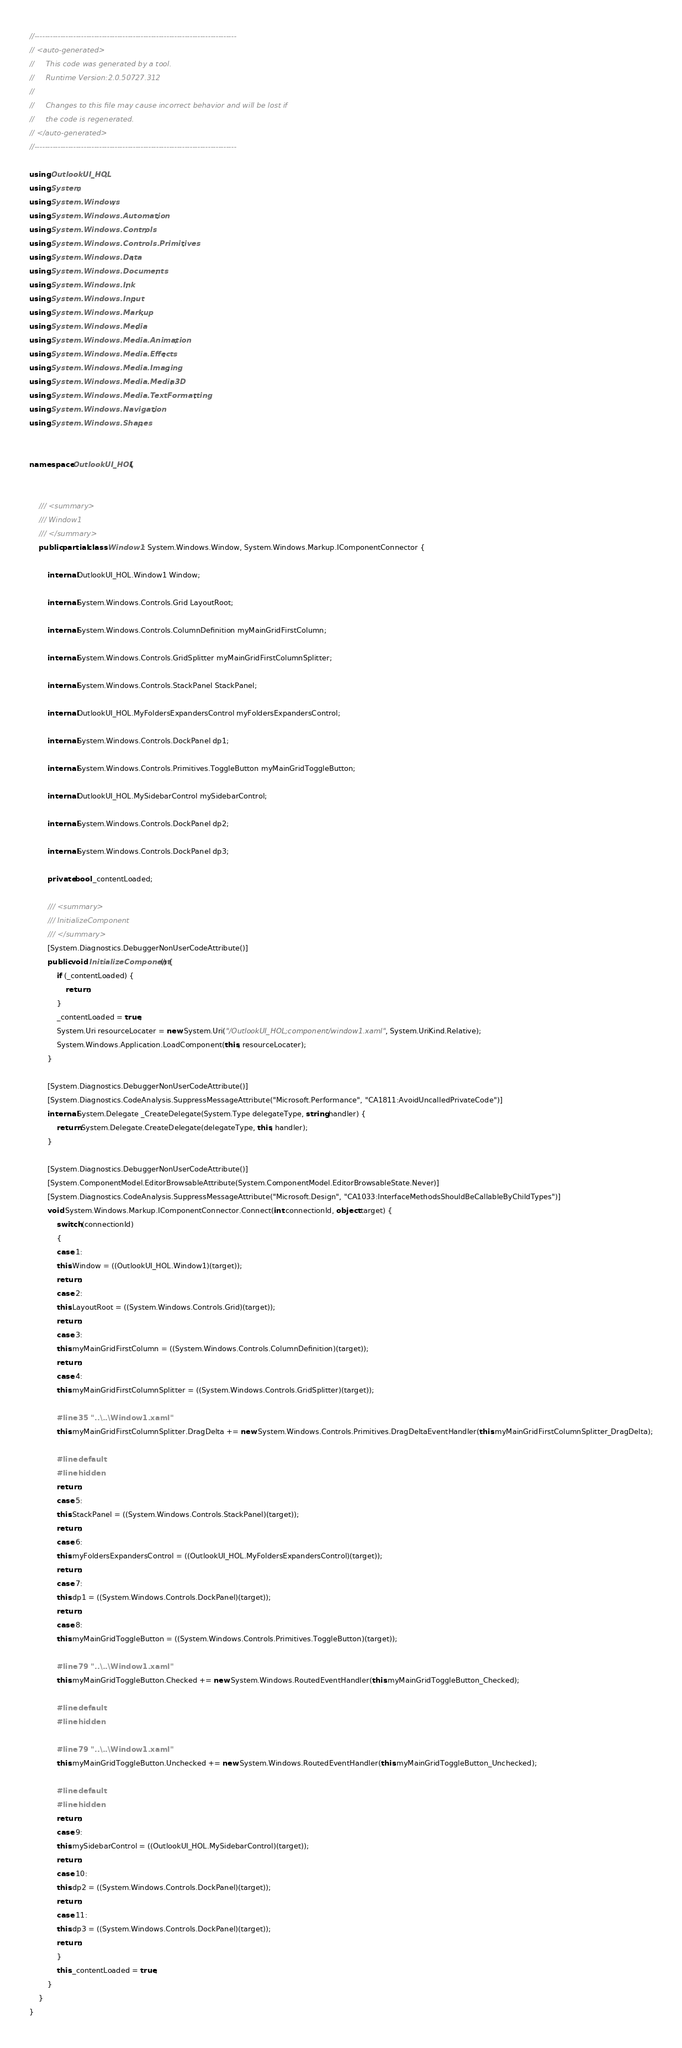<code> <loc_0><loc_0><loc_500><loc_500><_C#_>//------------------------------------------------------------------------------
// <auto-generated>
//     This code was generated by a tool.
//     Runtime Version:2.0.50727.312
//
//     Changes to this file may cause incorrect behavior and will be lost if
//     the code is regenerated.
// </auto-generated>
//------------------------------------------------------------------------------

using OutlookUI_HOL;
using System;
using System.Windows;
using System.Windows.Automation;
using System.Windows.Controls;
using System.Windows.Controls.Primitives;
using System.Windows.Data;
using System.Windows.Documents;
using System.Windows.Ink;
using System.Windows.Input;
using System.Windows.Markup;
using System.Windows.Media;
using System.Windows.Media.Animation;
using System.Windows.Media.Effects;
using System.Windows.Media.Imaging;
using System.Windows.Media.Media3D;
using System.Windows.Media.TextFormatting;
using System.Windows.Navigation;
using System.Windows.Shapes;


namespace OutlookUI_HOL {
    
    
    /// <summary>
    /// Window1
    /// </summary>
    public partial class Window1 : System.Windows.Window, System.Windows.Markup.IComponentConnector {
        
        internal OutlookUI_HOL.Window1 Window;
        
        internal System.Windows.Controls.Grid LayoutRoot;
        
        internal System.Windows.Controls.ColumnDefinition myMainGridFirstColumn;
        
        internal System.Windows.Controls.GridSplitter myMainGridFirstColumnSplitter;
        
        internal System.Windows.Controls.StackPanel StackPanel;
        
        internal OutlookUI_HOL.MyFoldersExpandersControl myFoldersExpandersControl;
        
        internal System.Windows.Controls.DockPanel dp1;
        
        internal System.Windows.Controls.Primitives.ToggleButton myMainGridToggleButton;
        
        internal OutlookUI_HOL.MySidebarControl mySidebarControl;
        
        internal System.Windows.Controls.DockPanel dp2;
        
        internal System.Windows.Controls.DockPanel dp3;
        
        private bool _contentLoaded;
        
        /// <summary>
        /// InitializeComponent
        /// </summary>
        [System.Diagnostics.DebuggerNonUserCodeAttribute()]
        public void InitializeComponent() {
            if (_contentLoaded) {
                return;
            }
            _contentLoaded = true;
            System.Uri resourceLocater = new System.Uri("/OutlookUI_HOL;component/window1.xaml", System.UriKind.Relative);
            System.Windows.Application.LoadComponent(this, resourceLocater);
        }
        
        [System.Diagnostics.DebuggerNonUserCodeAttribute()]
        [System.Diagnostics.CodeAnalysis.SuppressMessageAttribute("Microsoft.Performance", "CA1811:AvoidUncalledPrivateCode")]
        internal System.Delegate _CreateDelegate(System.Type delegateType, string handler) {
            return System.Delegate.CreateDelegate(delegateType, this, handler);
        }
        
        [System.Diagnostics.DebuggerNonUserCodeAttribute()]
        [System.ComponentModel.EditorBrowsableAttribute(System.ComponentModel.EditorBrowsableState.Never)]
        [System.Diagnostics.CodeAnalysis.SuppressMessageAttribute("Microsoft.Design", "CA1033:InterfaceMethodsShouldBeCallableByChildTypes")]
        void System.Windows.Markup.IComponentConnector.Connect(int connectionId, object target) {
            switch (connectionId)
            {
            case 1:
            this.Window = ((OutlookUI_HOL.Window1)(target));
            return;
            case 2:
            this.LayoutRoot = ((System.Windows.Controls.Grid)(target));
            return;
            case 3:
            this.myMainGridFirstColumn = ((System.Windows.Controls.ColumnDefinition)(target));
            return;
            case 4:
            this.myMainGridFirstColumnSplitter = ((System.Windows.Controls.GridSplitter)(target));
            
            #line 35 "..\..\Window1.xaml"
            this.myMainGridFirstColumnSplitter.DragDelta += new System.Windows.Controls.Primitives.DragDeltaEventHandler(this.myMainGridFirstColumnSplitter_DragDelta);
            
            #line default
            #line hidden
            return;
            case 5:
            this.StackPanel = ((System.Windows.Controls.StackPanel)(target));
            return;
            case 6:
            this.myFoldersExpandersControl = ((OutlookUI_HOL.MyFoldersExpandersControl)(target));
            return;
            case 7:
            this.dp1 = ((System.Windows.Controls.DockPanel)(target));
            return;
            case 8:
            this.myMainGridToggleButton = ((System.Windows.Controls.Primitives.ToggleButton)(target));
            
            #line 79 "..\..\Window1.xaml"
            this.myMainGridToggleButton.Checked += new System.Windows.RoutedEventHandler(this.myMainGridToggleButton_Checked);
            
            #line default
            #line hidden
            
            #line 79 "..\..\Window1.xaml"
            this.myMainGridToggleButton.Unchecked += new System.Windows.RoutedEventHandler(this.myMainGridToggleButton_Unchecked);
            
            #line default
            #line hidden
            return;
            case 9:
            this.mySidebarControl = ((OutlookUI_HOL.MySidebarControl)(target));
            return;
            case 10:
            this.dp2 = ((System.Windows.Controls.DockPanel)(target));
            return;
            case 11:
            this.dp3 = ((System.Windows.Controls.DockPanel)(target));
            return;
            }
            this._contentLoaded = true;
        }
    }
}
</code> 